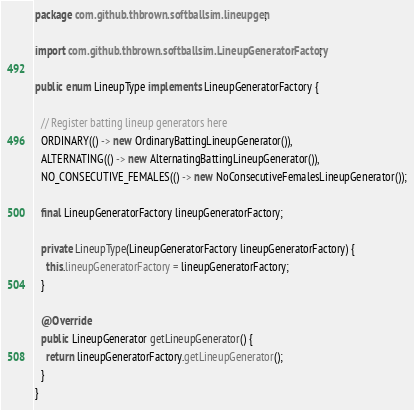Convert code to text. <code><loc_0><loc_0><loc_500><loc_500><_Java_>package com.github.thbrown.softballsim.lineupgen;

import com.github.thbrown.softballsim.LineupGeneratorFactory;

public enum LineupType implements LineupGeneratorFactory {

  // Register batting lineup generators here
  ORDINARY(() -> new OrdinaryBattingLineupGenerator()),
  ALTERNATING(() -> new AlternatingBattingLineupGenerator()),
  NO_CONSECUTIVE_FEMALES(() -> new NoConsecutiveFemalesLineupGenerator());

  final LineupGeneratorFactory lineupGeneratorFactory;

  private LineupType(LineupGeneratorFactory lineupGeneratorFactory) {
    this.lineupGeneratorFactory = lineupGeneratorFactory;
  }

  @Override
  public LineupGenerator getLineupGenerator() {
    return lineupGeneratorFactory.getLineupGenerator();
  }
}
</code> 